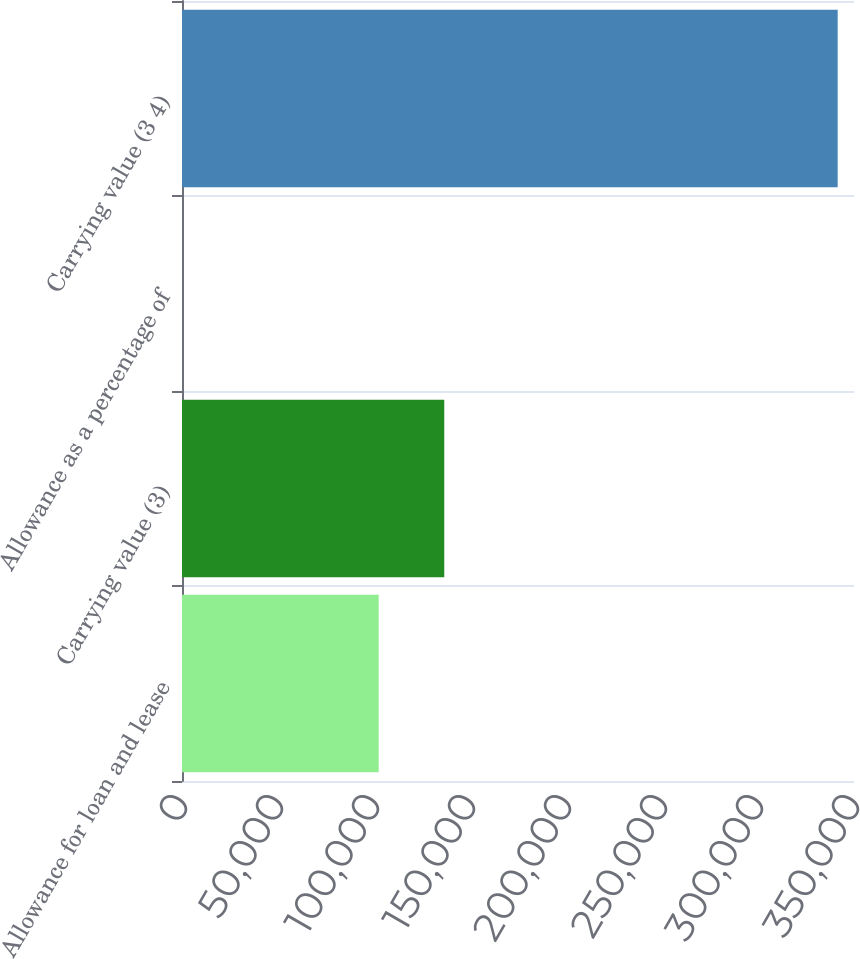Convert chart. <chart><loc_0><loc_0><loc_500><loc_500><bar_chart><fcel>Allowance for loan and lease<fcel>Carrying value (3)<fcel>Allowance as a percentage of<fcel>Carrying value (3 4)<nl><fcel>102451<fcel>136601<fcel>0.81<fcel>341502<nl></chart> 